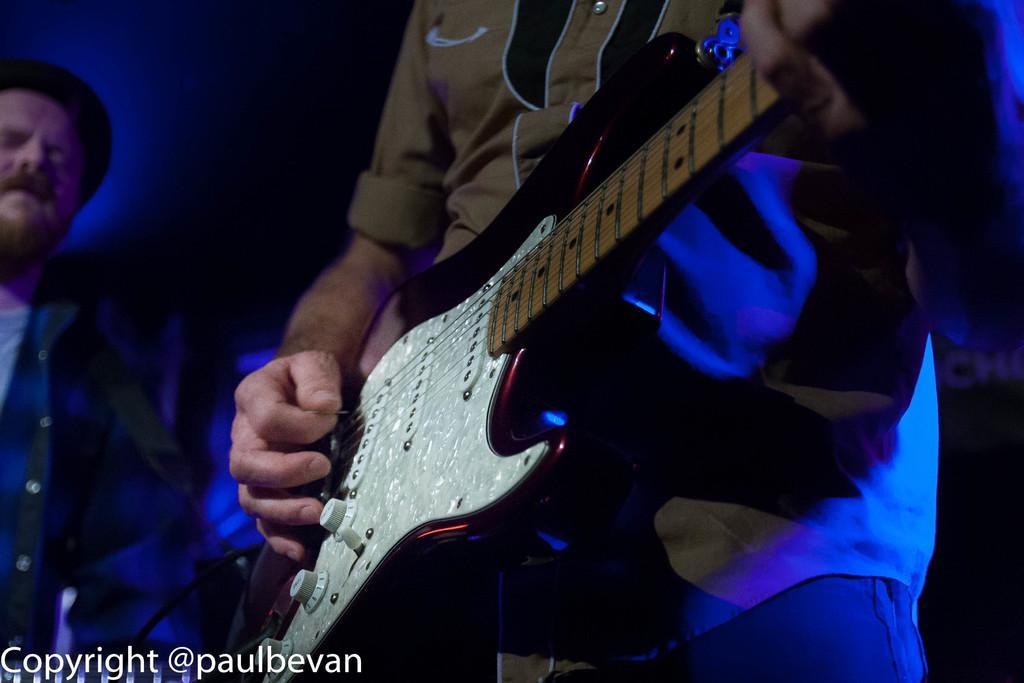Could you give a brief overview of what you see in this image? In this image i can see a man holding a guitar and wearing a brown color shirt. On the left side a man stand and wearing a cap. On the left corner there is a text written on the image. 